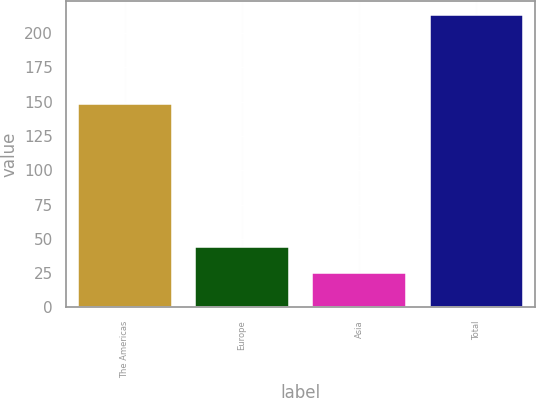Convert chart. <chart><loc_0><loc_0><loc_500><loc_500><bar_chart><fcel>The Americas<fcel>Europe<fcel>Asia<fcel>Total<nl><fcel>148<fcel>43.8<fcel>25<fcel>213<nl></chart> 